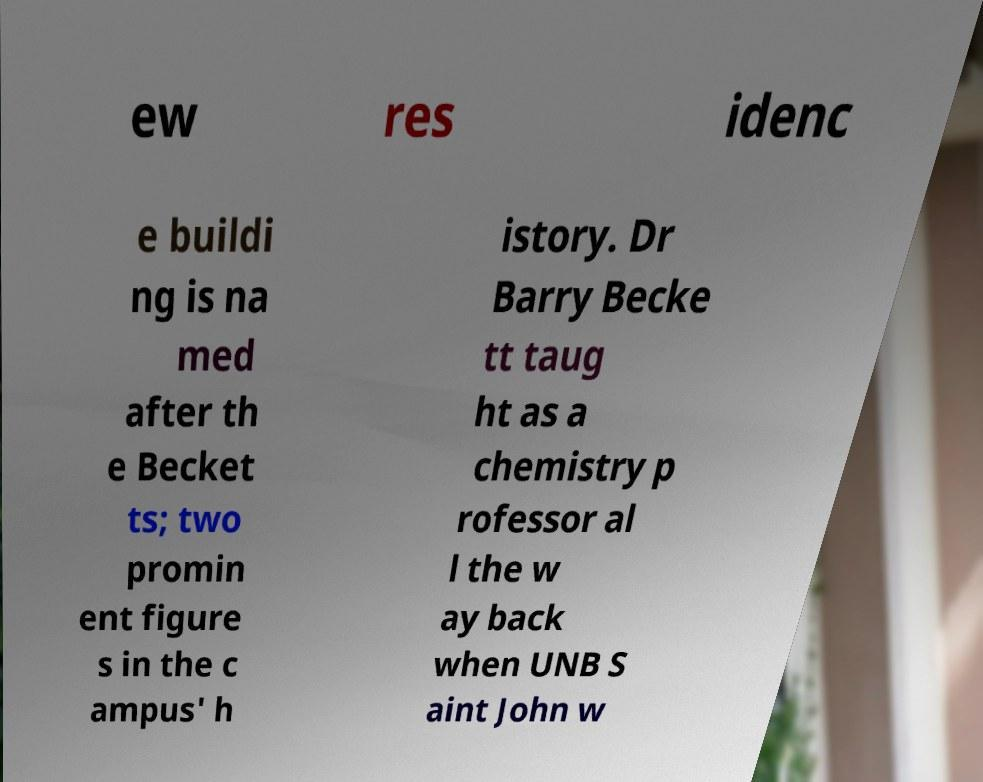I need the written content from this picture converted into text. Can you do that? ew res idenc e buildi ng is na med after th e Becket ts; two promin ent figure s in the c ampus' h istory. Dr Barry Becke tt taug ht as a chemistry p rofessor al l the w ay back when UNB S aint John w 